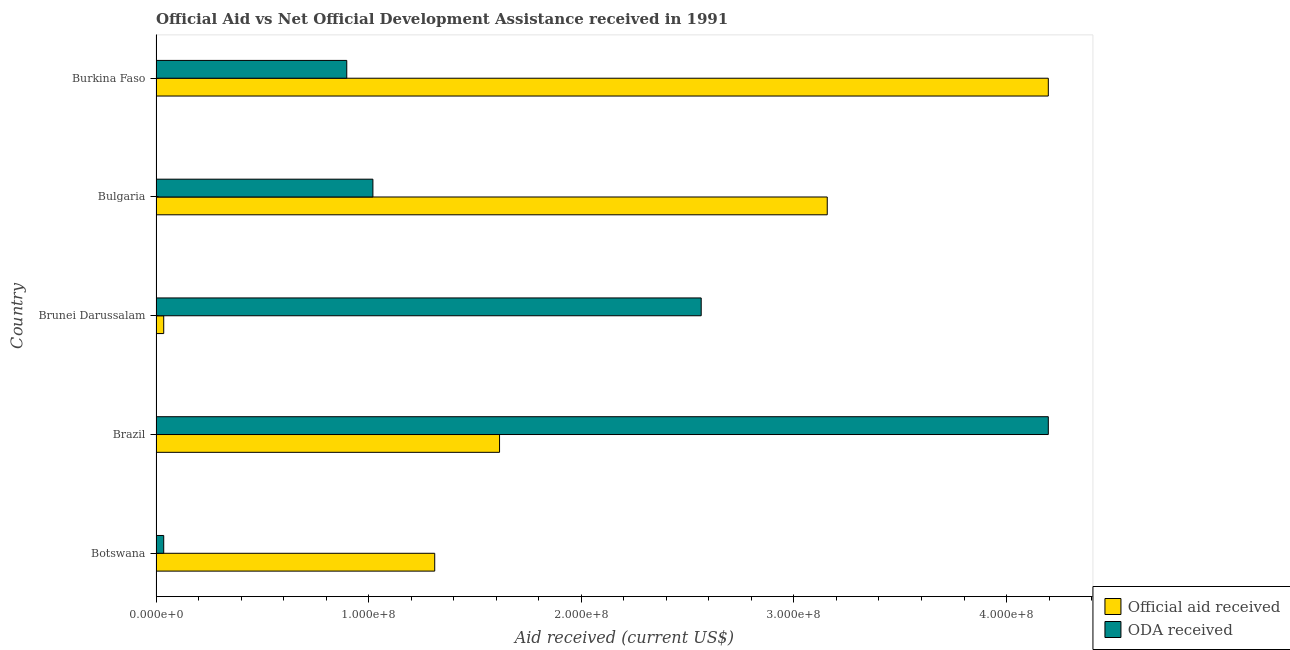Are the number of bars per tick equal to the number of legend labels?
Make the answer very short. Yes. Are the number of bars on each tick of the Y-axis equal?
Provide a short and direct response. Yes. What is the label of the 2nd group of bars from the top?
Ensure brevity in your answer.  Bulgaria. What is the official aid received in Burkina Faso?
Keep it short and to the point. 4.20e+08. Across all countries, what is the maximum official aid received?
Provide a short and direct response. 4.20e+08. Across all countries, what is the minimum oda received?
Make the answer very short. 3.62e+06. In which country was the oda received maximum?
Provide a succinct answer. Brazil. In which country was the oda received minimum?
Your response must be concise. Botswana. What is the total oda received in the graph?
Provide a short and direct response. 8.71e+08. What is the difference between the official aid received in Botswana and that in Brunei Darussalam?
Offer a terse response. 1.27e+08. What is the difference between the official aid received in Brazil and the oda received in Brunei Darussalam?
Offer a very short reply. -9.48e+07. What is the average official aid received per country?
Keep it short and to the point. 2.06e+08. What is the difference between the official aid received and oda received in Brazil?
Your answer should be very brief. -2.58e+08. What is the ratio of the oda received in Brazil to that in Bulgaria?
Provide a succinct answer. 4.11. What is the difference between the highest and the second highest official aid received?
Give a very brief answer. 1.04e+08. What is the difference between the highest and the lowest official aid received?
Your response must be concise. 4.16e+08. In how many countries, is the oda received greater than the average oda received taken over all countries?
Provide a succinct answer. 2. Is the sum of the official aid received in Botswana and Bulgaria greater than the maximum oda received across all countries?
Your answer should be very brief. Yes. What does the 2nd bar from the top in Brazil represents?
Provide a succinct answer. Official aid received. What does the 1st bar from the bottom in Botswana represents?
Your answer should be compact. Official aid received. Are all the bars in the graph horizontal?
Provide a short and direct response. Yes. Where does the legend appear in the graph?
Keep it short and to the point. Bottom right. How are the legend labels stacked?
Your answer should be very brief. Vertical. What is the title of the graph?
Offer a terse response. Official Aid vs Net Official Development Assistance received in 1991 . What is the label or title of the X-axis?
Offer a very short reply. Aid received (current US$). What is the label or title of the Y-axis?
Ensure brevity in your answer.  Country. What is the Aid received (current US$) in Official aid received in Botswana?
Offer a very short reply. 1.31e+08. What is the Aid received (current US$) in ODA received in Botswana?
Offer a terse response. 3.62e+06. What is the Aid received (current US$) of Official aid received in Brazil?
Provide a short and direct response. 1.62e+08. What is the Aid received (current US$) of ODA received in Brazil?
Your answer should be compact. 4.20e+08. What is the Aid received (current US$) in Official aid received in Brunei Darussalam?
Make the answer very short. 3.62e+06. What is the Aid received (current US$) of ODA received in Brunei Darussalam?
Offer a terse response. 2.56e+08. What is the Aid received (current US$) in Official aid received in Bulgaria?
Offer a very short reply. 3.16e+08. What is the Aid received (current US$) in ODA received in Bulgaria?
Your response must be concise. 1.02e+08. What is the Aid received (current US$) of Official aid received in Burkina Faso?
Provide a succinct answer. 4.20e+08. What is the Aid received (current US$) of ODA received in Burkina Faso?
Offer a very short reply. 8.97e+07. Across all countries, what is the maximum Aid received (current US$) in Official aid received?
Your answer should be very brief. 4.20e+08. Across all countries, what is the maximum Aid received (current US$) of ODA received?
Your answer should be compact. 4.20e+08. Across all countries, what is the minimum Aid received (current US$) of Official aid received?
Give a very brief answer. 3.62e+06. Across all countries, what is the minimum Aid received (current US$) in ODA received?
Your answer should be very brief. 3.62e+06. What is the total Aid received (current US$) in Official aid received in the graph?
Ensure brevity in your answer.  1.03e+09. What is the total Aid received (current US$) of ODA received in the graph?
Keep it short and to the point. 8.71e+08. What is the difference between the Aid received (current US$) in Official aid received in Botswana and that in Brazil?
Provide a short and direct response. -3.05e+07. What is the difference between the Aid received (current US$) in ODA received in Botswana and that in Brazil?
Your answer should be compact. -4.16e+08. What is the difference between the Aid received (current US$) of Official aid received in Botswana and that in Brunei Darussalam?
Your answer should be very brief. 1.27e+08. What is the difference between the Aid received (current US$) in ODA received in Botswana and that in Brunei Darussalam?
Provide a short and direct response. -2.53e+08. What is the difference between the Aid received (current US$) of Official aid received in Botswana and that in Bulgaria?
Your answer should be very brief. -1.85e+08. What is the difference between the Aid received (current US$) in ODA received in Botswana and that in Bulgaria?
Give a very brief answer. -9.84e+07. What is the difference between the Aid received (current US$) in Official aid received in Botswana and that in Burkina Faso?
Offer a terse response. -2.89e+08. What is the difference between the Aid received (current US$) in ODA received in Botswana and that in Burkina Faso?
Ensure brevity in your answer.  -8.61e+07. What is the difference between the Aid received (current US$) in Official aid received in Brazil and that in Brunei Darussalam?
Provide a short and direct response. 1.58e+08. What is the difference between the Aid received (current US$) of ODA received in Brazil and that in Brunei Darussalam?
Provide a short and direct response. 1.63e+08. What is the difference between the Aid received (current US$) of Official aid received in Brazil and that in Bulgaria?
Your response must be concise. -1.54e+08. What is the difference between the Aid received (current US$) of ODA received in Brazil and that in Bulgaria?
Make the answer very short. 3.18e+08. What is the difference between the Aid received (current US$) of Official aid received in Brazil and that in Burkina Faso?
Offer a terse response. -2.58e+08. What is the difference between the Aid received (current US$) of ODA received in Brazil and that in Burkina Faso?
Your response must be concise. 3.30e+08. What is the difference between the Aid received (current US$) in Official aid received in Brunei Darussalam and that in Bulgaria?
Keep it short and to the point. -3.12e+08. What is the difference between the Aid received (current US$) in ODA received in Brunei Darussalam and that in Bulgaria?
Give a very brief answer. 1.54e+08. What is the difference between the Aid received (current US$) of Official aid received in Brunei Darussalam and that in Burkina Faso?
Offer a very short reply. -4.16e+08. What is the difference between the Aid received (current US$) in ODA received in Brunei Darussalam and that in Burkina Faso?
Ensure brevity in your answer.  1.67e+08. What is the difference between the Aid received (current US$) of Official aid received in Bulgaria and that in Burkina Faso?
Your answer should be compact. -1.04e+08. What is the difference between the Aid received (current US$) in ODA received in Bulgaria and that in Burkina Faso?
Provide a short and direct response. 1.23e+07. What is the difference between the Aid received (current US$) of Official aid received in Botswana and the Aid received (current US$) of ODA received in Brazil?
Give a very brief answer. -2.89e+08. What is the difference between the Aid received (current US$) of Official aid received in Botswana and the Aid received (current US$) of ODA received in Brunei Darussalam?
Offer a very short reply. -1.25e+08. What is the difference between the Aid received (current US$) in Official aid received in Botswana and the Aid received (current US$) in ODA received in Bulgaria?
Provide a succinct answer. 2.91e+07. What is the difference between the Aid received (current US$) in Official aid received in Botswana and the Aid received (current US$) in ODA received in Burkina Faso?
Your answer should be compact. 4.14e+07. What is the difference between the Aid received (current US$) in Official aid received in Brazil and the Aid received (current US$) in ODA received in Brunei Darussalam?
Offer a very short reply. -9.48e+07. What is the difference between the Aid received (current US$) of Official aid received in Brazil and the Aid received (current US$) of ODA received in Bulgaria?
Make the answer very short. 5.96e+07. What is the difference between the Aid received (current US$) of Official aid received in Brazil and the Aid received (current US$) of ODA received in Burkina Faso?
Ensure brevity in your answer.  7.18e+07. What is the difference between the Aid received (current US$) in Official aid received in Brunei Darussalam and the Aid received (current US$) in ODA received in Bulgaria?
Your answer should be very brief. -9.84e+07. What is the difference between the Aid received (current US$) in Official aid received in Brunei Darussalam and the Aid received (current US$) in ODA received in Burkina Faso?
Your response must be concise. -8.61e+07. What is the difference between the Aid received (current US$) in Official aid received in Bulgaria and the Aid received (current US$) in ODA received in Burkina Faso?
Your answer should be compact. 2.26e+08. What is the average Aid received (current US$) of Official aid received per country?
Give a very brief answer. 2.06e+08. What is the average Aid received (current US$) of ODA received per country?
Your answer should be very brief. 1.74e+08. What is the difference between the Aid received (current US$) in Official aid received and Aid received (current US$) in ODA received in Botswana?
Offer a very short reply. 1.27e+08. What is the difference between the Aid received (current US$) in Official aid received and Aid received (current US$) in ODA received in Brazil?
Offer a very short reply. -2.58e+08. What is the difference between the Aid received (current US$) in Official aid received and Aid received (current US$) in ODA received in Brunei Darussalam?
Provide a short and direct response. -2.53e+08. What is the difference between the Aid received (current US$) in Official aid received and Aid received (current US$) in ODA received in Bulgaria?
Provide a succinct answer. 2.14e+08. What is the difference between the Aid received (current US$) in Official aid received and Aid received (current US$) in ODA received in Burkina Faso?
Ensure brevity in your answer.  3.30e+08. What is the ratio of the Aid received (current US$) in Official aid received in Botswana to that in Brazil?
Make the answer very short. 0.81. What is the ratio of the Aid received (current US$) of ODA received in Botswana to that in Brazil?
Your answer should be compact. 0.01. What is the ratio of the Aid received (current US$) of Official aid received in Botswana to that in Brunei Darussalam?
Offer a very short reply. 36.21. What is the ratio of the Aid received (current US$) in ODA received in Botswana to that in Brunei Darussalam?
Offer a very short reply. 0.01. What is the ratio of the Aid received (current US$) of Official aid received in Botswana to that in Bulgaria?
Provide a short and direct response. 0.42. What is the ratio of the Aid received (current US$) in ODA received in Botswana to that in Bulgaria?
Provide a succinct answer. 0.04. What is the ratio of the Aid received (current US$) of Official aid received in Botswana to that in Burkina Faso?
Offer a very short reply. 0.31. What is the ratio of the Aid received (current US$) in ODA received in Botswana to that in Burkina Faso?
Offer a very short reply. 0.04. What is the ratio of the Aid received (current US$) of Official aid received in Brazil to that in Brunei Darussalam?
Your response must be concise. 44.63. What is the ratio of the Aid received (current US$) of ODA received in Brazil to that in Brunei Darussalam?
Offer a terse response. 1.64. What is the ratio of the Aid received (current US$) in Official aid received in Brazil to that in Bulgaria?
Ensure brevity in your answer.  0.51. What is the ratio of the Aid received (current US$) in ODA received in Brazil to that in Bulgaria?
Your response must be concise. 4.11. What is the ratio of the Aid received (current US$) of Official aid received in Brazil to that in Burkina Faso?
Offer a terse response. 0.39. What is the ratio of the Aid received (current US$) of ODA received in Brazil to that in Burkina Faso?
Offer a terse response. 4.68. What is the ratio of the Aid received (current US$) of Official aid received in Brunei Darussalam to that in Bulgaria?
Make the answer very short. 0.01. What is the ratio of the Aid received (current US$) of ODA received in Brunei Darussalam to that in Bulgaria?
Your answer should be very brief. 2.51. What is the ratio of the Aid received (current US$) in Official aid received in Brunei Darussalam to that in Burkina Faso?
Keep it short and to the point. 0.01. What is the ratio of the Aid received (current US$) in ODA received in Brunei Darussalam to that in Burkina Faso?
Keep it short and to the point. 2.86. What is the ratio of the Aid received (current US$) in Official aid received in Bulgaria to that in Burkina Faso?
Provide a succinct answer. 0.75. What is the ratio of the Aid received (current US$) of ODA received in Bulgaria to that in Burkina Faso?
Provide a succinct answer. 1.14. What is the difference between the highest and the second highest Aid received (current US$) of Official aid received?
Provide a short and direct response. 1.04e+08. What is the difference between the highest and the second highest Aid received (current US$) in ODA received?
Keep it short and to the point. 1.63e+08. What is the difference between the highest and the lowest Aid received (current US$) of Official aid received?
Provide a short and direct response. 4.16e+08. What is the difference between the highest and the lowest Aid received (current US$) in ODA received?
Offer a terse response. 4.16e+08. 